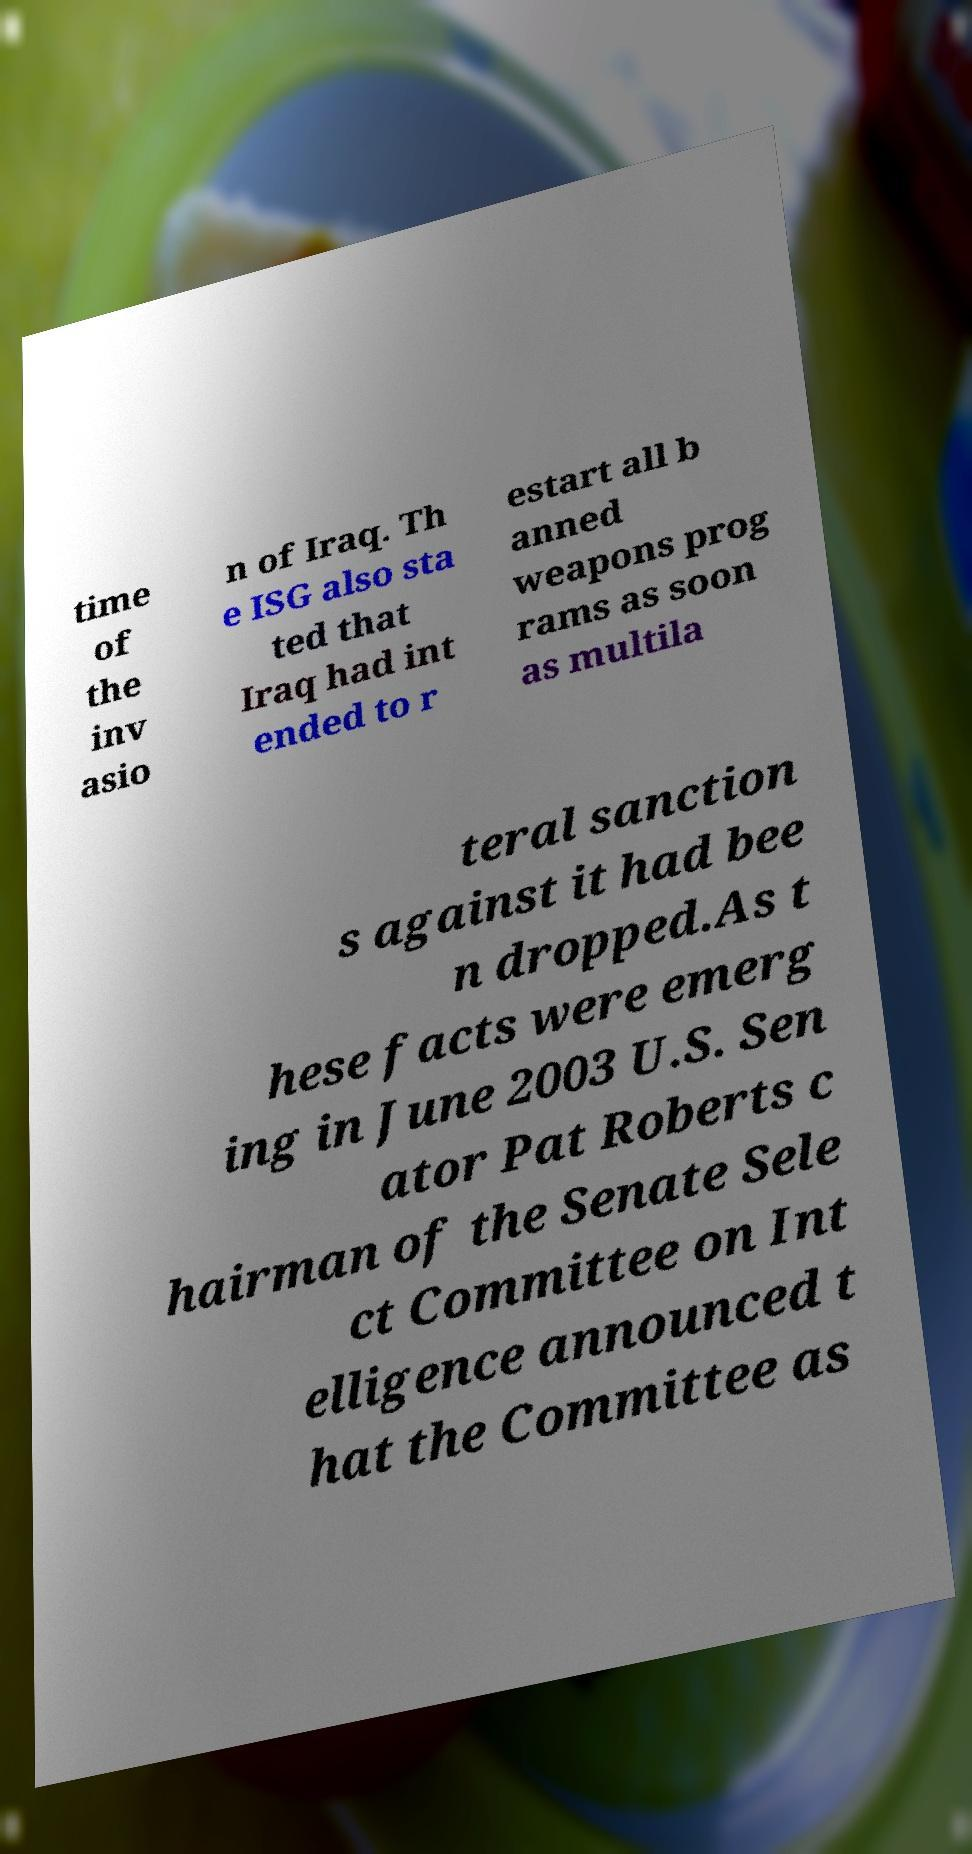Can you accurately transcribe the text from the provided image for me? time of the inv asio n of Iraq. Th e ISG also sta ted that Iraq had int ended to r estart all b anned weapons prog rams as soon as multila teral sanction s against it had bee n dropped.As t hese facts were emerg ing in June 2003 U.S. Sen ator Pat Roberts c hairman of the Senate Sele ct Committee on Int elligence announced t hat the Committee as 